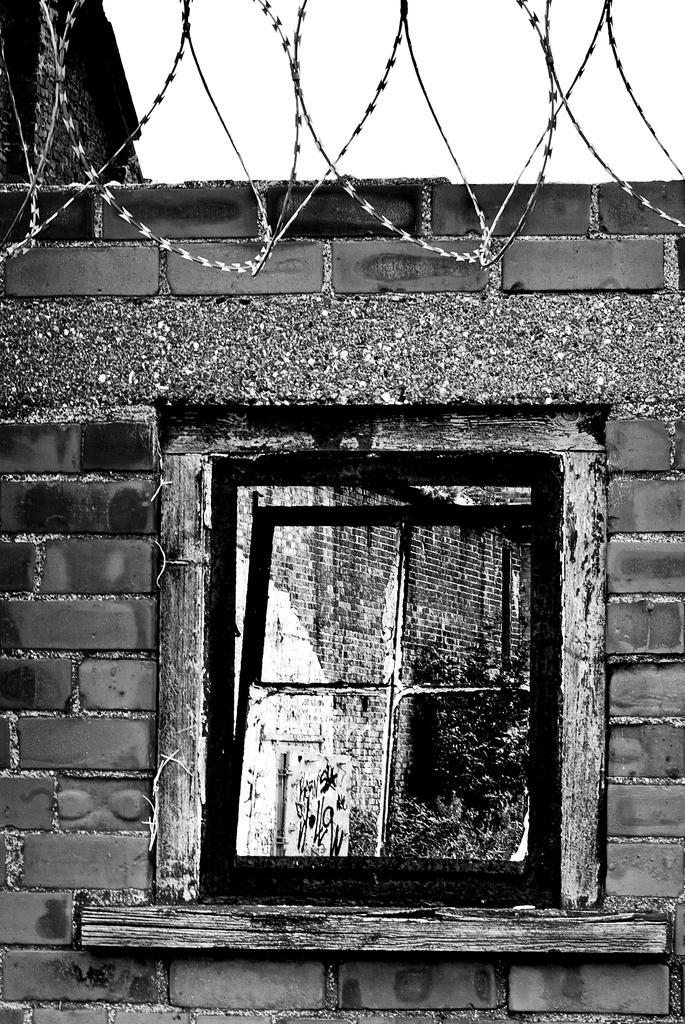Can you describe this image briefly? It looks like a black and white picture. We can see a wall with a wooden window. Behind the wooden window there are trees and behind the wall it looks like the sky. In front of the wall there are cables. 